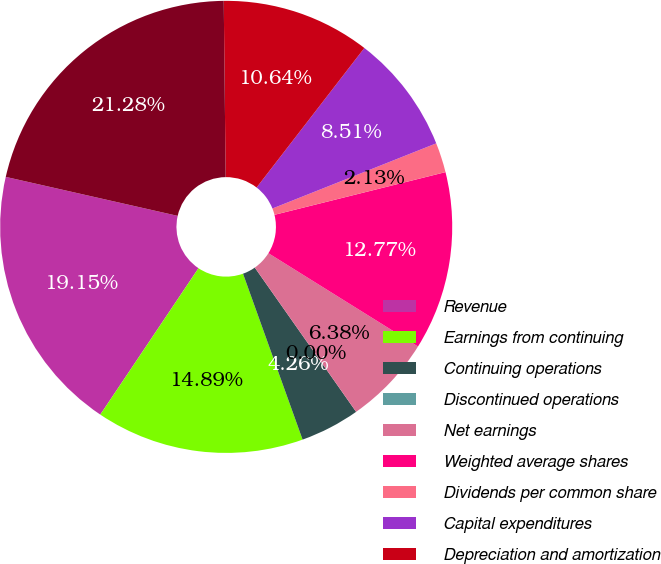<chart> <loc_0><loc_0><loc_500><loc_500><pie_chart><fcel>Revenue<fcel>Earnings from continuing<fcel>Continuing operations<fcel>Discontinued operations<fcel>Net earnings<fcel>Weighted average shares<fcel>Dividends per common share<fcel>Capital expenditures<fcel>Depreciation and amortization<fcel>Total assets<nl><fcel>19.15%<fcel>14.89%<fcel>4.26%<fcel>0.0%<fcel>6.38%<fcel>12.77%<fcel>2.13%<fcel>8.51%<fcel>10.64%<fcel>21.28%<nl></chart> 